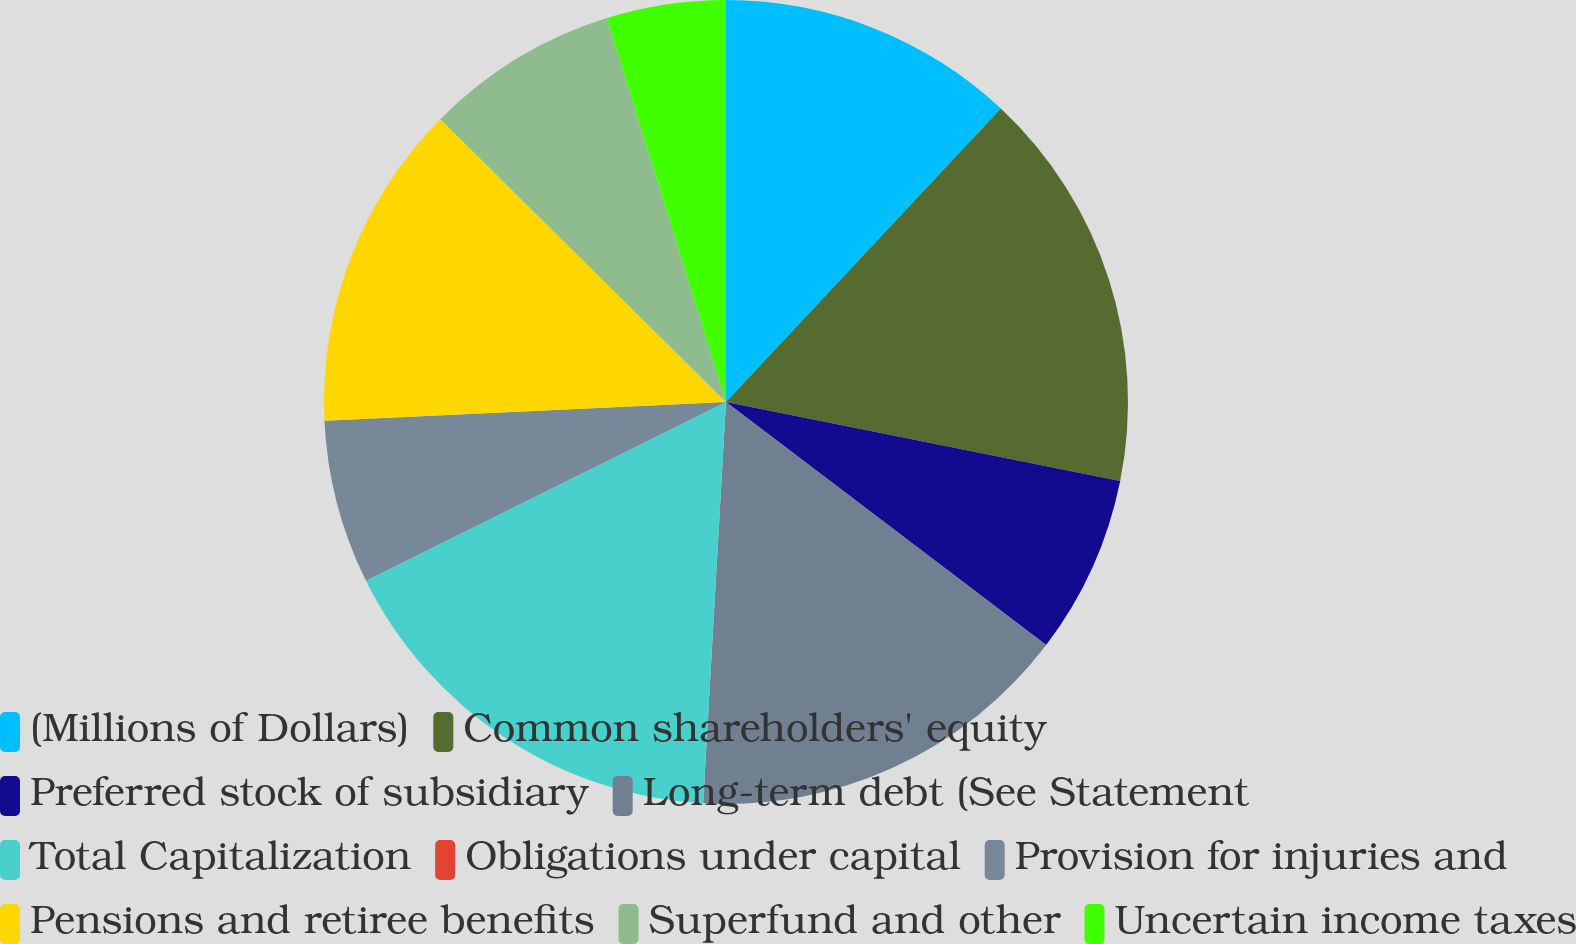Convert chart to OTSL. <chart><loc_0><loc_0><loc_500><loc_500><pie_chart><fcel>(Millions of Dollars)<fcel>Common shareholders' equity<fcel>Preferred stock of subsidiary<fcel>Long-term debt (See Statement<fcel>Total Capitalization<fcel>Obligations under capital<fcel>Provision for injuries and<fcel>Pensions and retiree benefits<fcel>Superfund and other<fcel>Uncertain income taxes<nl><fcel>11.98%<fcel>16.17%<fcel>7.19%<fcel>15.57%<fcel>16.76%<fcel>0.0%<fcel>6.59%<fcel>13.17%<fcel>7.79%<fcel>4.79%<nl></chart> 